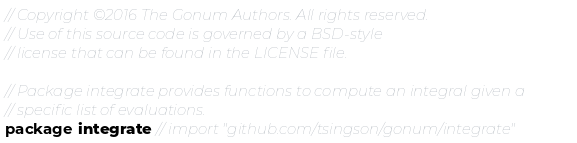<code> <loc_0><loc_0><loc_500><loc_500><_Go_>// Copyright ©2016 The Gonum Authors. All rights reserved.
// Use of this source code is governed by a BSD-style
// license that can be found in the LICENSE file.

// Package integrate provides functions to compute an integral given a
// specific list of evaluations.
package integrate // import "github.com/tsingson/gonum/integrate"
</code> 